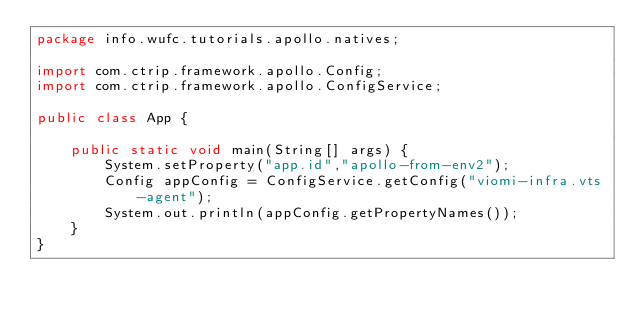<code> <loc_0><loc_0><loc_500><loc_500><_Java_>package info.wufc.tutorials.apollo.natives;

import com.ctrip.framework.apollo.Config;
import com.ctrip.framework.apollo.ConfigService;

public class App {

    public static void main(String[] args) {
        System.setProperty("app.id","apollo-from-env2");
        Config appConfig = ConfigService.getConfig("viomi-infra.vts-agent");
        System.out.println(appConfig.getPropertyNames());
    }
}
</code> 